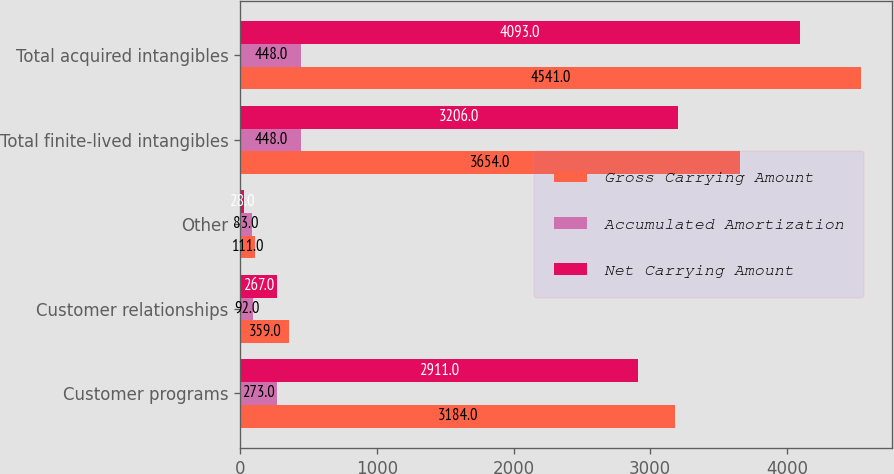<chart> <loc_0><loc_0><loc_500><loc_500><stacked_bar_chart><ecel><fcel>Customer programs<fcel>Customer relationships<fcel>Other<fcel>Total finite-lived intangibles<fcel>Total acquired intangibles<nl><fcel>Gross Carrying Amount<fcel>3184<fcel>359<fcel>111<fcel>3654<fcel>4541<nl><fcel>Accumulated Amortization<fcel>273<fcel>92<fcel>83<fcel>448<fcel>448<nl><fcel>Net Carrying Amount<fcel>2911<fcel>267<fcel>28<fcel>3206<fcel>4093<nl></chart> 